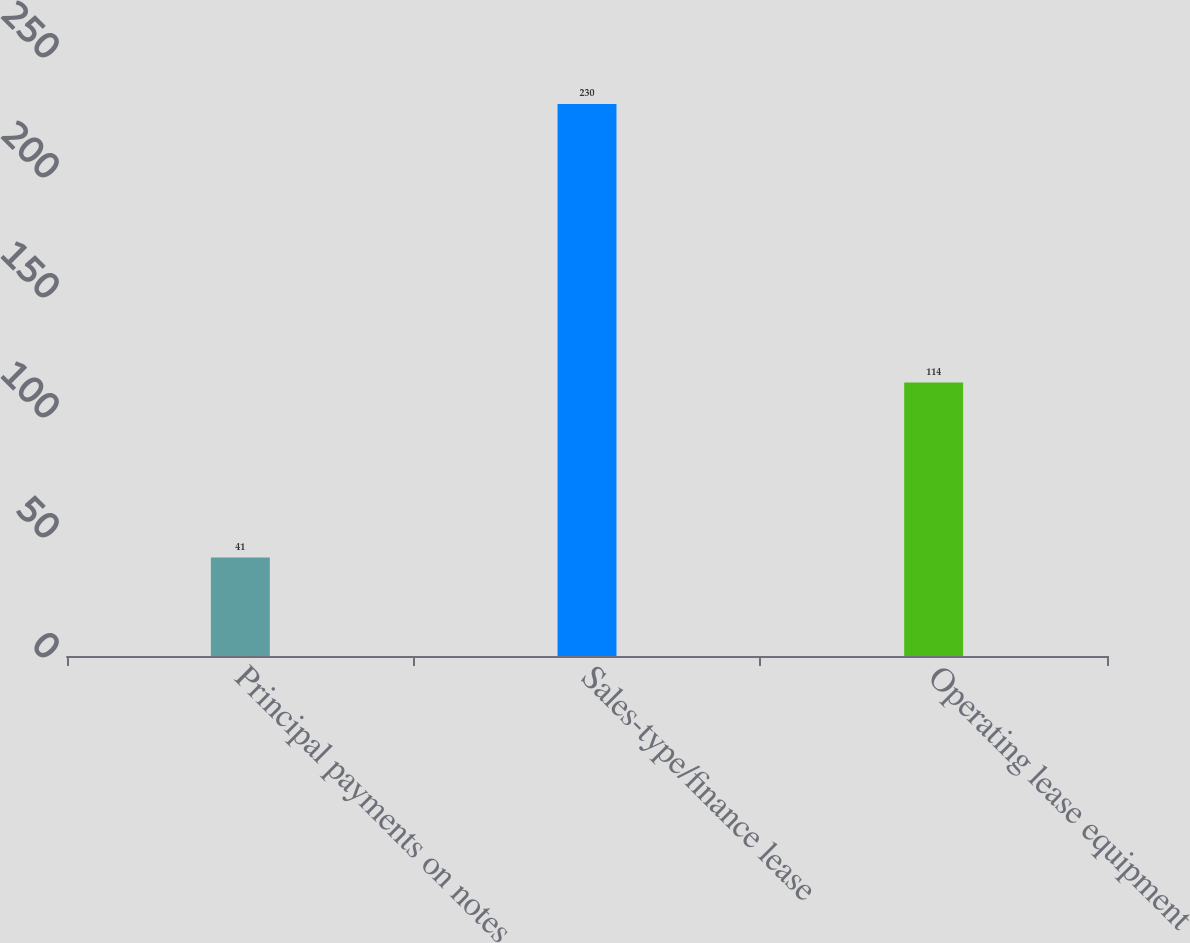Convert chart. <chart><loc_0><loc_0><loc_500><loc_500><bar_chart><fcel>Principal payments on notes<fcel>Sales-type/finance lease<fcel>Operating lease equipment<nl><fcel>41<fcel>230<fcel>114<nl></chart> 